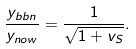<formula> <loc_0><loc_0><loc_500><loc_500>\frac { y _ { b b n } } { y _ { n o w } } = \frac { 1 } { \sqrt { 1 + v _ { S } } } .</formula> 